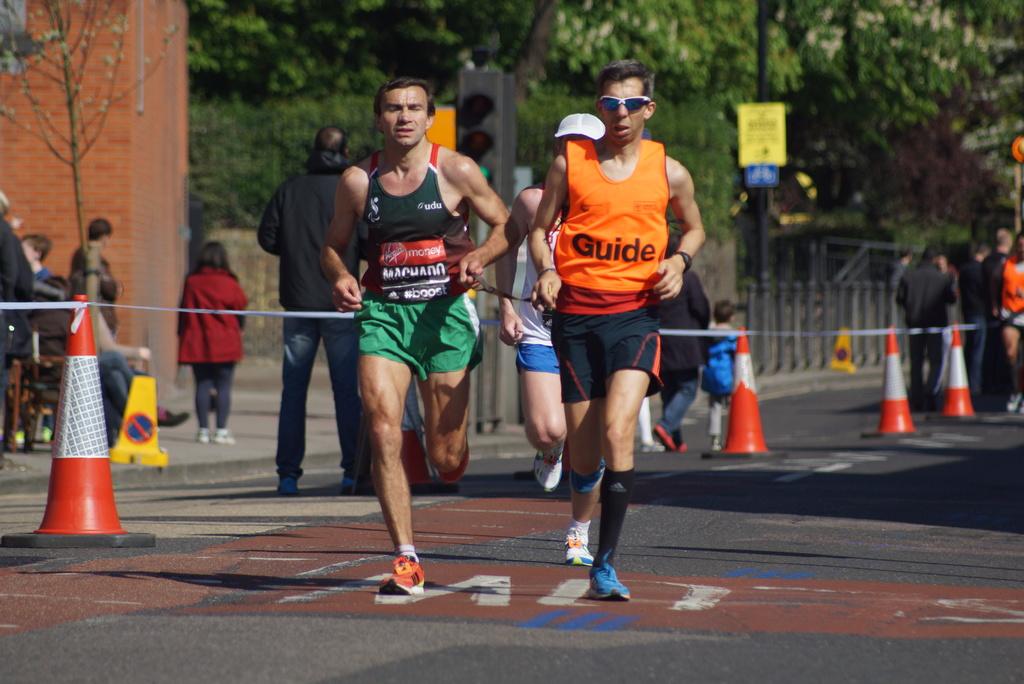What role is the man with the orange vest playing?
Provide a succinct answer. Guide. What is the jersey brand on the right?
Give a very brief answer. Guide. 